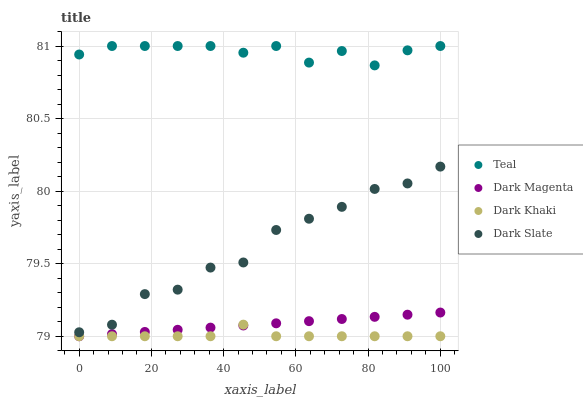Does Dark Khaki have the minimum area under the curve?
Answer yes or no. Yes. Does Teal have the maximum area under the curve?
Answer yes or no. Yes. Does Dark Slate have the minimum area under the curve?
Answer yes or no. No. Does Dark Slate have the maximum area under the curve?
Answer yes or no. No. Is Dark Magenta the smoothest?
Answer yes or no. Yes. Is Dark Slate the roughest?
Answer yes or no. Yes. Is Dark Slate the smoothest?
Answer yes or no. No. Is Dark Magenta the roughest?
Answer yes or no. No. Does Dark Khaki have the lowest value?
Answer yes or no. Yes. Does Dark Slate have the lowest value?
Answer yes or no. No. Does Teal have the highest value?
Answer yes or no. Yes. Does Dark Slate have the highest value?
Answer yes or no. No. Is Dark Khaki less than Dark Slate?
Answer yes or no. Yes. Is Dark Slate greater than Dark Khaki?
Answer yes or no. Yes. Does Dark Magenta intersect Dark Khaki?
Answer yes or no. Yes. Is Dark Magenta less than Dark Khaki?
Answer yes or no. No. Is Dark Magenta greater than Dark Khaki?
Answer yes or no. No. Does Dark Khaki intersect Dark Slate?
Answer yes or no. No. 